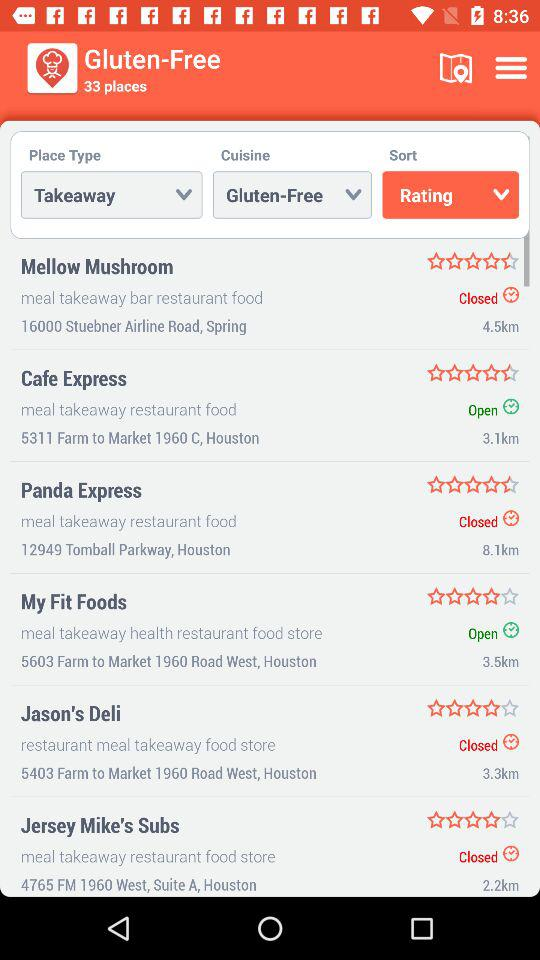What is the selected sort order? The selected sort order is "Rating". 